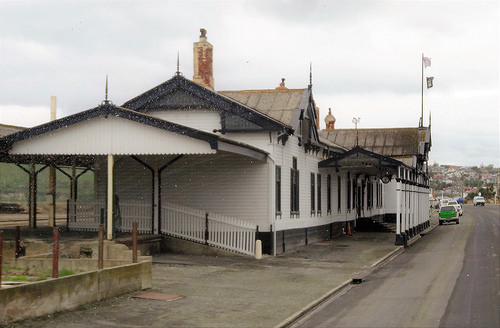<image>
Can you confirm if the building is next to the road? Yes. The building is positioned adjacent to the road, located nearby in the same general area. 